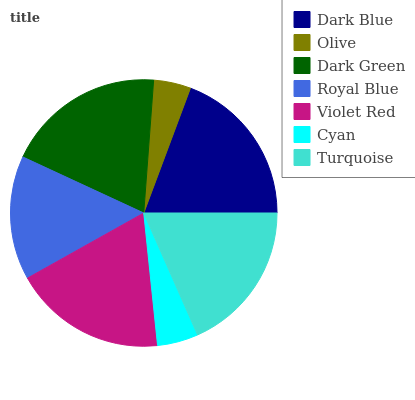Is Olive the minimum?
Answer yes or no. Yes. Is Dark Blue the maximum?
Answer yes or no. Yes. Is Dark Green the minimum?
Answer yes or no. No. Is Dark Green the maximum?
Answer yes or no. No. Is Dark Green greater than Olive?
Answer yes or no. Yes. Is Olive less than Dark Green?
Answer yes or no. Yes. Is Olive greater than Dark Green?
Answer yes or no. No. Is Dark Green less than Olive?
Answer yes or no. No. Is Turquoise the high median?
Answer yes or no. Yes. Is Turquoise the low median?
Answer yes or no. Yes. Is Olive the high median?
Answer yes or no. No. Is Violet Red the low median?
Answer yes or no. No. 